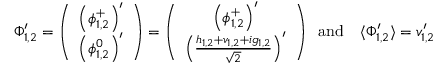<formula> <loc_0><loc_0><loc_500><loc_500>\Phi _ { 1 , 2 } ^ { \prime } = \left ( \begin{array} { c } { { \left ( \phi _ { 1 , 2 } ^ { + } \right ) ^ { \prime } } } \\ { { \left ( \phi _ { 1 , 2 } ^ { 0 } \right ) ^ { \prime } } } \end{array} \right ) = \left ( \begin{array} { c } { { \left ( \phi _ { 1 , 2 } ^ { + } \right ) ^ { \prime } } } \\ { { \left ( \frac { h _ { 1 , 2 } + v _ { 1 , 2 } + i g _ { 1 , 2 } } { \sqrt { 2 } } \right ) ^ { \prime } } } \end{array} \right ) \, a n d \quad \langle \Phi _ { 1 , 2 } ^ { \prime } \rangle = v _ { 1 , 2 } ^ { \prime }</formula> 